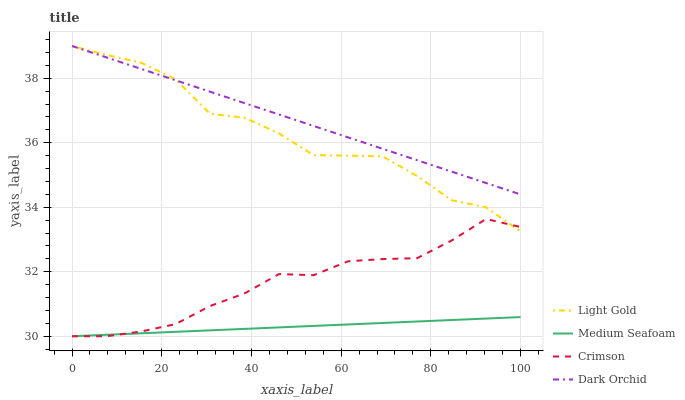Does Medium Seafoam have the minimum area under the curve?
Answer yes or no. Yes. Does Dark Orchid have the maximum area under the curve?
Answer yes or no. Yes. Does Light Gold have the minimum area under the curve?
Answer yes or no. No. Does Light Gold have the maximum area under the curve?
Answer yes or no. No. Is Dark Orchid the smoothest?
Answer yes or no. Yes. Is Light Gold the roughest?
Answer yes or no. Yes. Is Medium Seafoam the smoothest?
Answer yes or no. No. Is Medium Seafoam the roughest?
Answer yes or no. No. Does Crimson have the lowest value?
Answer yes or no. Yes. Does Light Gold have the lowest value?
Answer yes or no. No. Does Dark Orchid have the highest value?
Answer yes or no. Yes. Does Medium Seafoam have the highest value?
Answer yes or no. No. Is Medium Seafoam less than Light Gold?
Answer yes or no. Yes. Is Light Gold greater than Medium Seafoam?
Answer yes or no. Yes. Does Light Gold intersect Dark Orchid?
Answer yes or no. Yes. Is Light Gold less than Dark Orchid?
Answer yes or no. No. Is Light Gold greater than Dark Orchid?
Answer yes or no. No. Does Medium Seafoam intersect Light Gold?
Answer yes or no. No. 